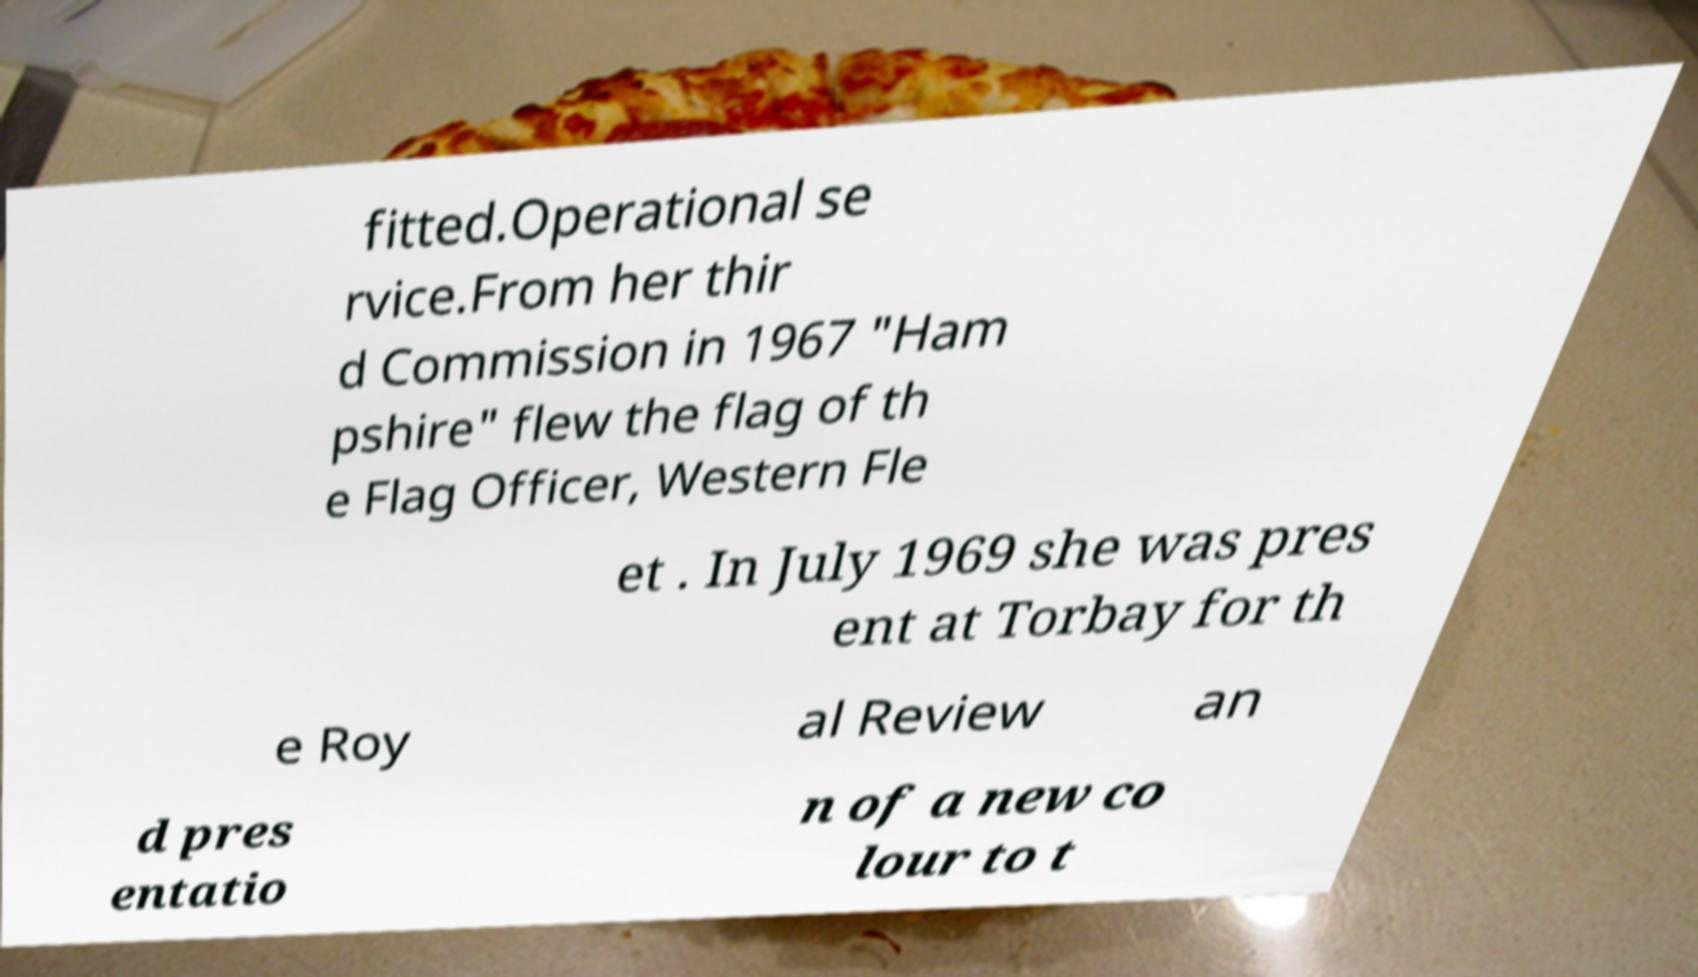Please read and relay the text visible in this image. What does it say? fitted.Operational se rvice.From her thir d Commission in 1967 "Ham pshire" flew the flag of th e Flag Officer, Western Fle et . In July 1969 she was pres ent at Torbay for th e Roy al Review an d pres entatio n of a new co lour to t 